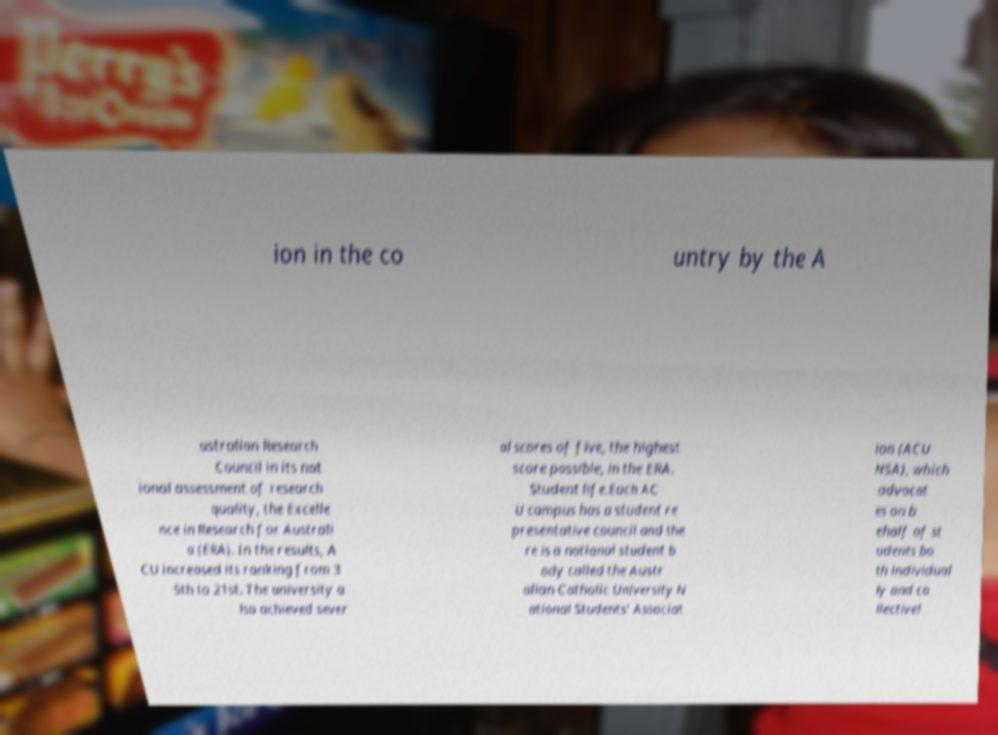Please read and relay the text visible in this image. What does it say? ion in the co untry by the A ustralian Research Council in its nat ional assessment of research quality, the Excelle nce in Research for Australi a (ERA). In the results, A CU increased its ranking from 3 5th to 21st. The university a lso achieved sever al scores of five, the highest score possible, in the ERA. Student life.Each AC U campus has a student re presentative council and the re is a national student b ody called the Austr alian Catholic University N ational Students' Associat ion (ACU NSA), which advocat es on b ehalf of st udents bo th individual ly and co llectivel 